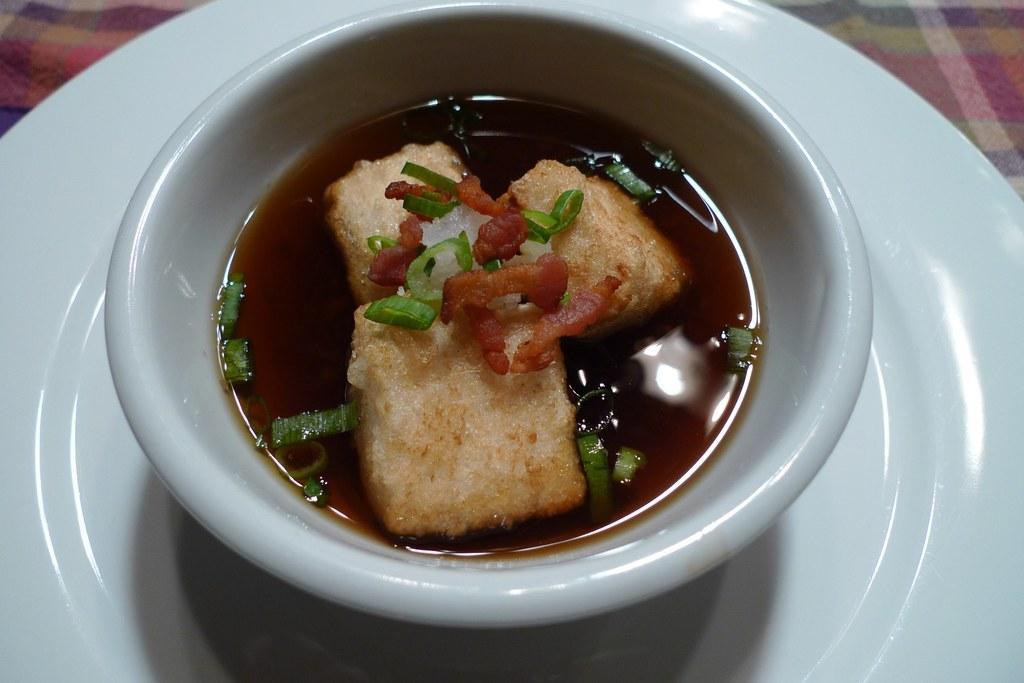Describe this image in one or two sentences. In this image, I can see a bowl with a food item. This bowl is placed on a plate. At the top left and right corner of the image, I can see a cloth. 